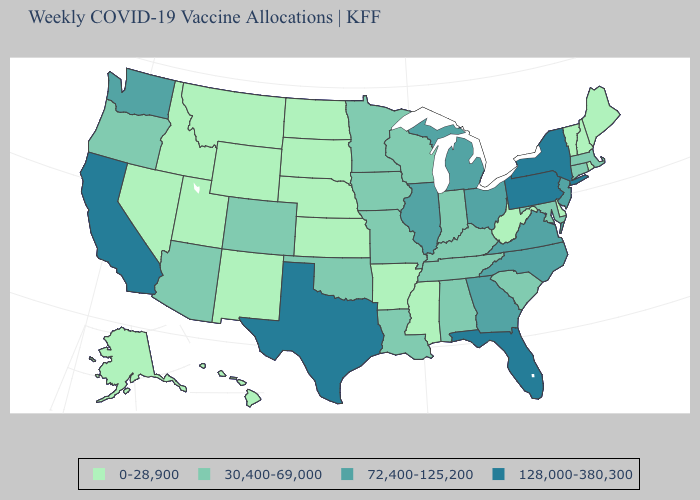Does the map have missing data?
Give a very brief answer. No. Does the map have missing data?
Keep it brief. No. Name the states that have a value in the range 0-28,900?
Short answer required. Alaska, Arkansas, Delaware, Hawaii, Idaho, Kansas, Maine, Mississippi, Montana, Nebraska, Nevada, New Hampshire, New Mexico, North Dakota, Rhode Island, South Dakota, Utah, Vermont, West Virginia, Wyoming. What is the value of Colorado?
Quick response, please. 30,400-69,000. What is the lowest value in states that border Indiana?
Write a very short answer. 30,400-69,000. What is the value of Alaska?
Answer briefly. 0-28,900. What is the lowest value in the West?
Write a very short answer. 0-28,900. What is the value of Utah?
Be succinct. 0-28,900. Which states have the highest value in the USA?
Concise answer only. California, Florida, New York, Pennsylvania, Texas. Among the states that border Texas , does New Mexico have the highest value?
Concise answer only. No. What is the highest value in states that border Missouri?
Give a very brief answer. 72,400-125,200. Does California have the highest value in the West?
Keep it brief. Yes. Does the first symbol in the legend represent the smallest category?
Concise answer only. Yes. Does Washington have the lowest value in the USA?
Concise answer only. No. What is the value of Florida?
Be succinct. 128,000-380,300. 